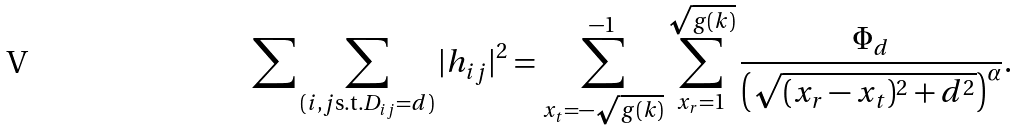Convert formula to latex. <formula><loc_0><loc_0><loc_500><loc_500>\sum \sum _ { ( i , j \text {s.t.} D _ { i j } = d ) } | h _ { i j } | ^ { 2 } = \sum _ { x _ { t } = - \sqrt { g ( k ) } } ^ { - 1 } \sum _ { x _ { r } = 1 } ^ { \sqrt { g ( k ) } } \frac { \Phi _ { d } } { \left ( \sqrt { ( x _ { r } - x _ { t } ) ^ { 2 } + d ^ { 2 } } \right ) ^ { \alpha } } .</formula> 